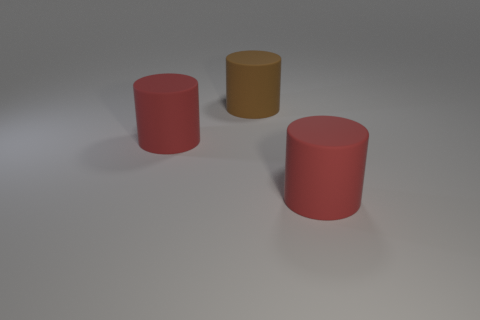There is a large red cylinder on the left side of the big red matte cylinder on the right side of the big brown thing; what number of big brown matte cylinders are in front of it?
Provide a short and direct response. 0. Are there any red things made of the same material as the large brown thing?
Make the answer very short. Yes. Are there fewer red matte things than large brown cylinders?
Ensure brevity in your answer.  No. What is the material of the large red cylinder in front of the big red cylinder that is behind the large matte cylinder that is on the right side of the big brown matte cylinder?
Give a very brief answer. Rubber. Is the number of red matte things that are left of the brown thing less than the number of big red matte cylinders?
Make the answer very short. Yes. Do the matte cylinder on the right side of the brown matte cylinder and the big brown cylinder have the same size?
Offer a terse response. Yes. What size is the red rubber object that is left of the large red cylinder that is to the right of the brown object?
Keep it short and to the point. Large. There is a rubber cylinder that is right of the brown cylinder; is it the same color as the large rubber object that is left of the brown cylinder?
Offer a very short reply. Yes. Are there any things?
Your answer should be very brief. Yes. Does the big brown rubber thing have the same shape as the large thing that is on the right side of the brown cylinder?
Offer a terse response. Yes. 